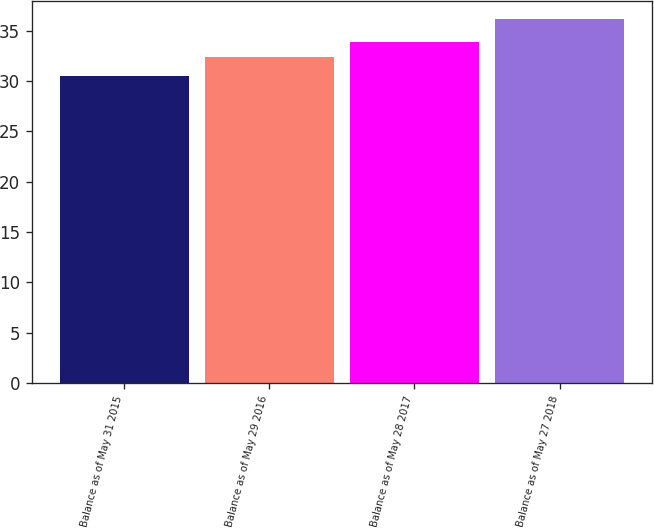<chart> <loc_0><loc_0><loc_500><loc_500><bar_chart><fcel>Balance as of May 31 2015<fcel>Balance as of May 29 2016<fcel>Balance as of May 28 2017<fcel>Balance as of May 27 2018<nl><fcel>30.44<fcel>32.38<fcel>33.83<fcel>36.15<nl></chart> 